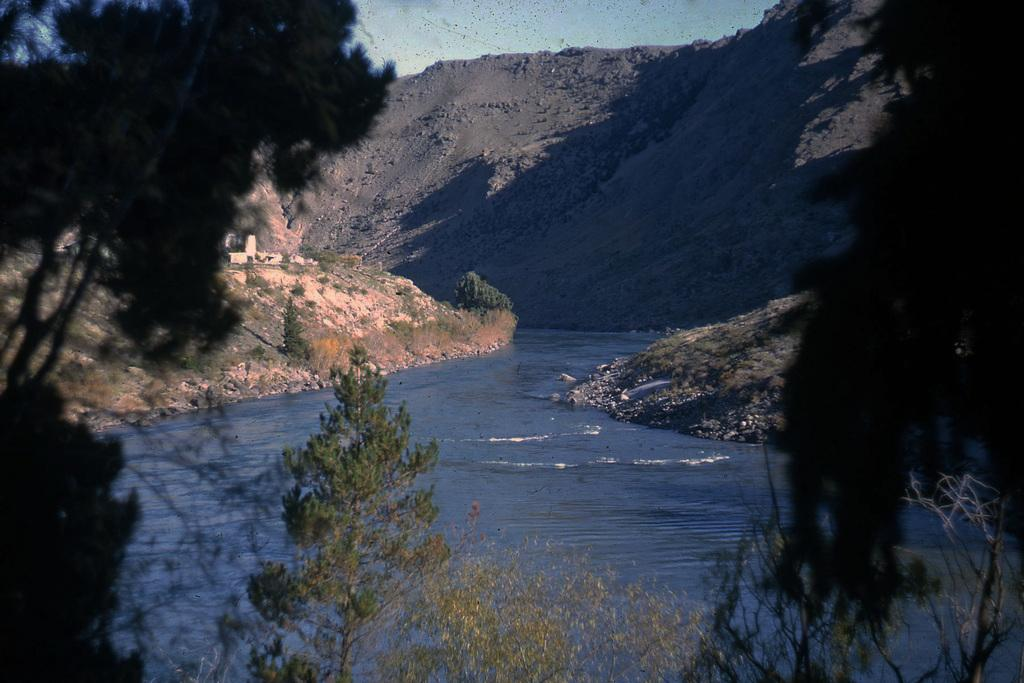What can be seen in the center of the image? The sky is visible in the center of the image. What type of natural features are present in the image? There are hills, trees, plants, and grass visible in the image. Is there any water visible in the image? Yes, there is water visible in the image. Are there any other objects in the image besides the natural features? Yes, there are a few other objects in the image. What is the price of the cream being sold in the image? There is no cream or any indication of a sale in the image. 